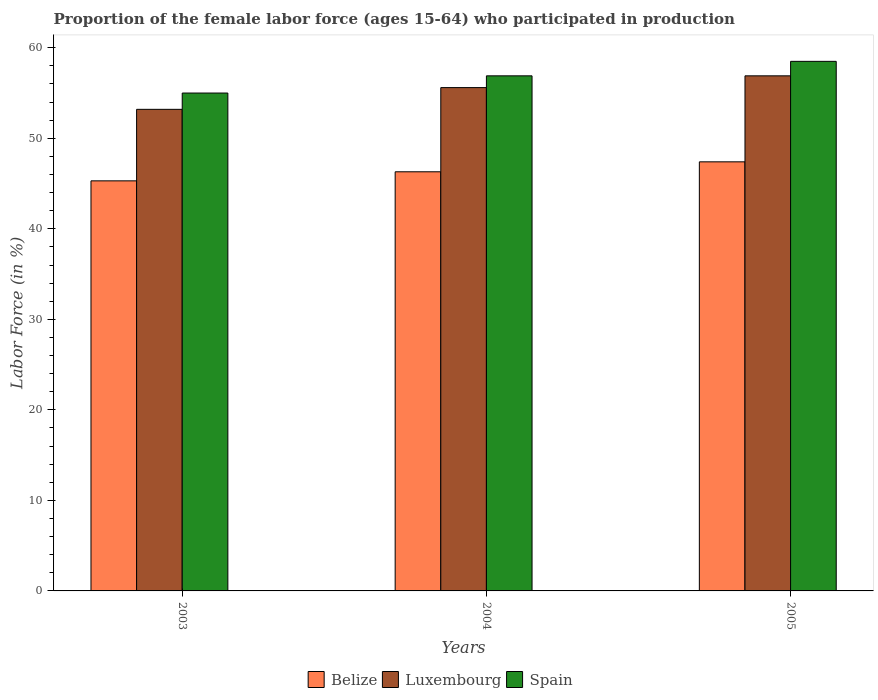How many different coloured bars are there?
Ensure brevity in your answer.  3. Are the number of bars per tick equal to the number of legend labels?
Keep it short and to the point. Yes. Are the number of bars on each tick of the X-axis equal?
Offer a terse response. Yes. How many bars are there on the 1st tick from the right?
Offer a terse response. 3. What is the label of the 1st group of bars from the left?
Provide a succinct answer. 2003. What is the proportion of the female labor force who participated in production in Belize in 2004?
Your response must be concise. 46.3. Across all years, what is the maximum proportion of the female labor force who participated in production in Belize?
Your answer should be compact. 47.4. Across all years, what is the minimum proportion of the female labor force who participated in production in Belize?
Offer a terse response. 45.3. In which year was the proportion of the female labor force who participated in production in Luxembourg maximum?
Offer a very short reply. 2005. What is the total proportion of the female labor force who participated in production in Belize in the graph?
Your answer should be very brief. 139. What is the difference between the proportion of the female labor force who participated in production in Belize in 2003 and that in 2004?
Provide a short and direct response. -1. What is the difference between the proportion of the female labor force who participated in production in Luxembourg in 2005 and the proportion of the female labor force who participated in production in Belize in 2004?
Make the answer very short. 10.6. What is the average proportion of the female labor force who participated in production in Spain per year?
Give a very brief answer. 56.8. In the year 2004, what is the difference between the proportion of the female labor force who participated in production in Belize and proportion of the female labor force who participated in production in Luxembourg?
Your answer should be very brief. -9.3. In how many years, is the proportion of the female labor force who participated in production in Spain greater than 48 %?
Your answer should be compact. 3. What is the ratio of the proportion of the female labor force who participated in production in Luxembourg in 2003 to that in 2005?
Provide a short and direct response. 0.93. Is the proportion of the female labor force who participated in production in Luxembourg in 2003 less than that in 2005?
Your answer should be compact. Yes. Is the difference between the proportion of the female labor force who participated in production in Belize in 2003 and 2005 greater than the difference between the proportion of the female labor force who participated in production in Luxembourg in 2003 and 2005?
Ensure brevity in your answer.  Yes. What is the difference between the highest and the second highest proportion of the female labor force who participated in production in Spain?
Make the answer very short. 1.6. What is the difference between the highest and the lowest proportion of the female labor force who participated in production in Luxembourg?
Your answer should be very brief. 3.7. In how many years, is the proportion of the female labor force who participated in production in Spain greater than the average proportion of the female labor force who participated in production in Spain taken over all years?
Offer a very short reply. 2. Is the sum of the proportion of the female labor force who participated in production in Luxembourg in 2003 and 2004 greater than the maximum proportion of the female labor force who participated in production in Spain across all years?
Offer a very short reply. Yes. What does the 1st bar from the left in 2004 represents?
Your response must be concise. Belize. What does the 3rd bar from the right in 2003 represents?
Your answer should be very brief. Belize. Is it the case that in every year, the sum of the proportion of the female labor force who participated in production in Spain and proportion of the female labor force who participated in production in Luxembourg is greater than the proportion of the female labor force who participated in production in Belize?
Provide a succinct answer. Yes. How many bars are there?
Provide a succinct answer. 9. Are all the bars in the graph horizontal?
Give a very brief answer. No. Are the values on the major ticks of Y-axis written in scientific E-notation?
Ensure brevity in your answer.  No. What is the title of the graph?
Make the answer very short. Proportion of the female labor force (ages 15-64) who participated in production. Does "Peru" appear as one of the legend labels in the graph?
Your answer should be compact. No. What is the Labor Force (in %) of Belize in 2003?
Provide a succinct answer. 45.3. What is the Labor Force (in %) in Luxembourg in 2003?
Provide a succinct answer. 53.2. What is the Labor Force (in %) in Spain in 2003?
Offer a very short reply. 55. What is the Labor Force (in %) of Belize in 2004?
Your response must be concise. 46.3. What is the Labor Force (in %) in Luxembourg in 2004?
Offer a very short reply. 55.6. What is the Labor Force (in %) of Spain in 2004?
Keep it short and to the point. 56.9. What is the Labor Force (in %) of Belize in 2005?
Provide a succinct answer. 47.4. What is the Labor Force (in %) of Luxembourg in 2005?
Give a very brief answer. 56.9. What is the Labor Force (in %) in Spain in 2005?
Keep it short and to the point. 58.5. Across all years, what is the maximum Labor Force (in %) of Belize?
Give a very brief answer. 47.4. Across all years, what is the maximum Labor Force (in %) of Luxembourg?
Your answer should be compact. 56.9. Across all years, what is the maximum Labor Force (in %) in Spain?
Provide a short and direct response. 58.5. Across all years, what is the minimum Labor Force (in %) in Belize?
Your answer should be very brief. 45.3. Across all years, what is the minimum Labor Force (in %) in Luxembourg?
Ensure brevity in your answer.  53.2. Across all years, what is the minimum Labor Force (in %) in Spain?
Keep it short and to the point. 55. What is the total Labor Force (in %) in Belize in the graph?
Your answer should be very brief. 139. What is the total Labor Force (in %) of Luxembourg in the graph?
Your answer should be very brief. 165.7. What is the total Labor Force (in %) in Spain in the graph?
Offer a very short reply. 170.4. What is the difference between the Labor Force (in %) in Spain in 2003 and that in 2004?
Give a very brief answer. -1.9. What is the difference between the Labor Force (in %) in Belize in 2003 and that in 2005?
Give a very brief answer. -2.1. What is the difference between the Labor Force (in %) in Luxembourg in 2003 and that in 2005?
Keep it short and to the point. -3.7. What is the difference between the Labor Force (in %) of Spain in 2003 and that in 2005?
Provide a short and direct response. -3.5. What is the difference between the Labor Force (in %) of Belize in 2004 and that in 2005?
Offer a very short reply. -1.1. What is the difference between the Labor Force (in %) in Belize in 2003 and the Labor Force (in %) in Luxembourg in 2004?
Your response must be concise. -10.3. What is the difference between the Labor Force (in %) in Belize in 2003 and the Labor Force (in %) in Spain in 2004?
Offer a terse response. -11.6. What is the difference between the Labor Force (in %) of Luxembourg in 2003 and the Labor Force (in %) of Spain in 2004?
Provide a short and direct response. -3.7. What is the difference between the Labor Force (in %) in Belize in 2003 and the Labor Force (in %) in Luxembourg in 2005?
Ensure brevity in your answer.  -11.6. What is the difference between the Labor Force (in %) in Belize in 2003 and the Labor Force (in %) in Spain in 2005?
Make the answer very short. -13.2. What is the difference between the Labor Force (in %) in Luxembourg in 2003 and the Labor Force (in %) in Spain in 2005?
Offer a terse response. -5.3. What is the difference between the Labor Force (in %) of Belize in 2004 and the Labor Force (in %) of Spain in 2005?
Your response must be concise. -12.2. What is the difference between the Labor Force (in %) of Luxembourg in 2004 and the Labor Force (in %) of Spain in 2005?
Make the answer very short. -2.9. What is the average Labor Force (in %) in Belize per year?
Provide a short and direct response. 46.33. What is the average Labor Force (in %) in Luxembourg per year?
Provide a short and direct response. 55.23. What is the average Labor Force (in %) of Spain per year?
Provide a short and direct response. 56.8. In the year 2003, what is the difference between the Labor Force (in %) in Belize and Labor Force (in %) in Luxembourg?
Your response must be concise. -7.9. In the year 2003, what is the difference between the Labor Force (in %) in Luxembourg and Labor Force (in %) in Spain?
Offer a very short reply. -1.8. In the year 2004, what is the difference between the Labor Force (in %) of Belize and Labor Force (in %) of Spain?
Ensure brevity in your answer.  -10.6. In the year 2004, what is the difference between the Labor Force (in %) in Luxembourg and Labor Force (in %) in Spain?
Keep it short and to the point. -1.3. In the year 2005, what is the difference between the Labor Force (in %) of Luxembourg and Labor Force (in %) of Spain?
Provide a succinct answer. -1.6. What is the ratio of the Labor Force (in %) of Belize in 2003 to that in 2004?
Ensure brevity in your answer.  0.98. What is the ratio of the Labor Force (in %) of Luxembourg in 2003 to that in 2004?
Your response must be concise. 0.96. What is the ratio of the Labor Force (in %) in Spain in 2003 to that in 2004?
Provide a succinct answer. 0.97. What is the ratio of the Labor Force (in %) of Belize in 2003 to that in 2005?
Offer a very short reply. 0.96. What is the ratio of the Labor Force (in %) of Luxembourg in 2003 to that in 2005?
Make the answer very short. 0.94. What is the ratio of the Labor Force (in %) of Spain in 2003 to that in 2005?
Keep it short and to the point. 0.94. What is the ratio of the Labor Force (in %) of Belize in 2004 to that in 2005?
Provide a succinct answer. 0.98. What is the ratio of the Labor Force (in %) of Luxembourg in 2004 to that in 2005?
Give a very brief answer. 0.98. What is the ratio of the Labor Force (in %) of Spain in 2004 to that in 2005?
Give a very brief answer. 0.97. What is the difference between the highest and the second highest Labor Force (in %) in Luxembourg?
Provide a succinct answer. 1.3. What is the difference between the highest and the lowest Labor Force (in %) in Belize?
Make the answer very short. 2.1. What is the difference between the highest and the lowest Labor Force (in %) of Luxembourg?
Keep it short and to the point. 3.7. What is the difference between the highest and the lowest Labor Force (in %) of Spain?
Provide a succinct answer. 3.5. 